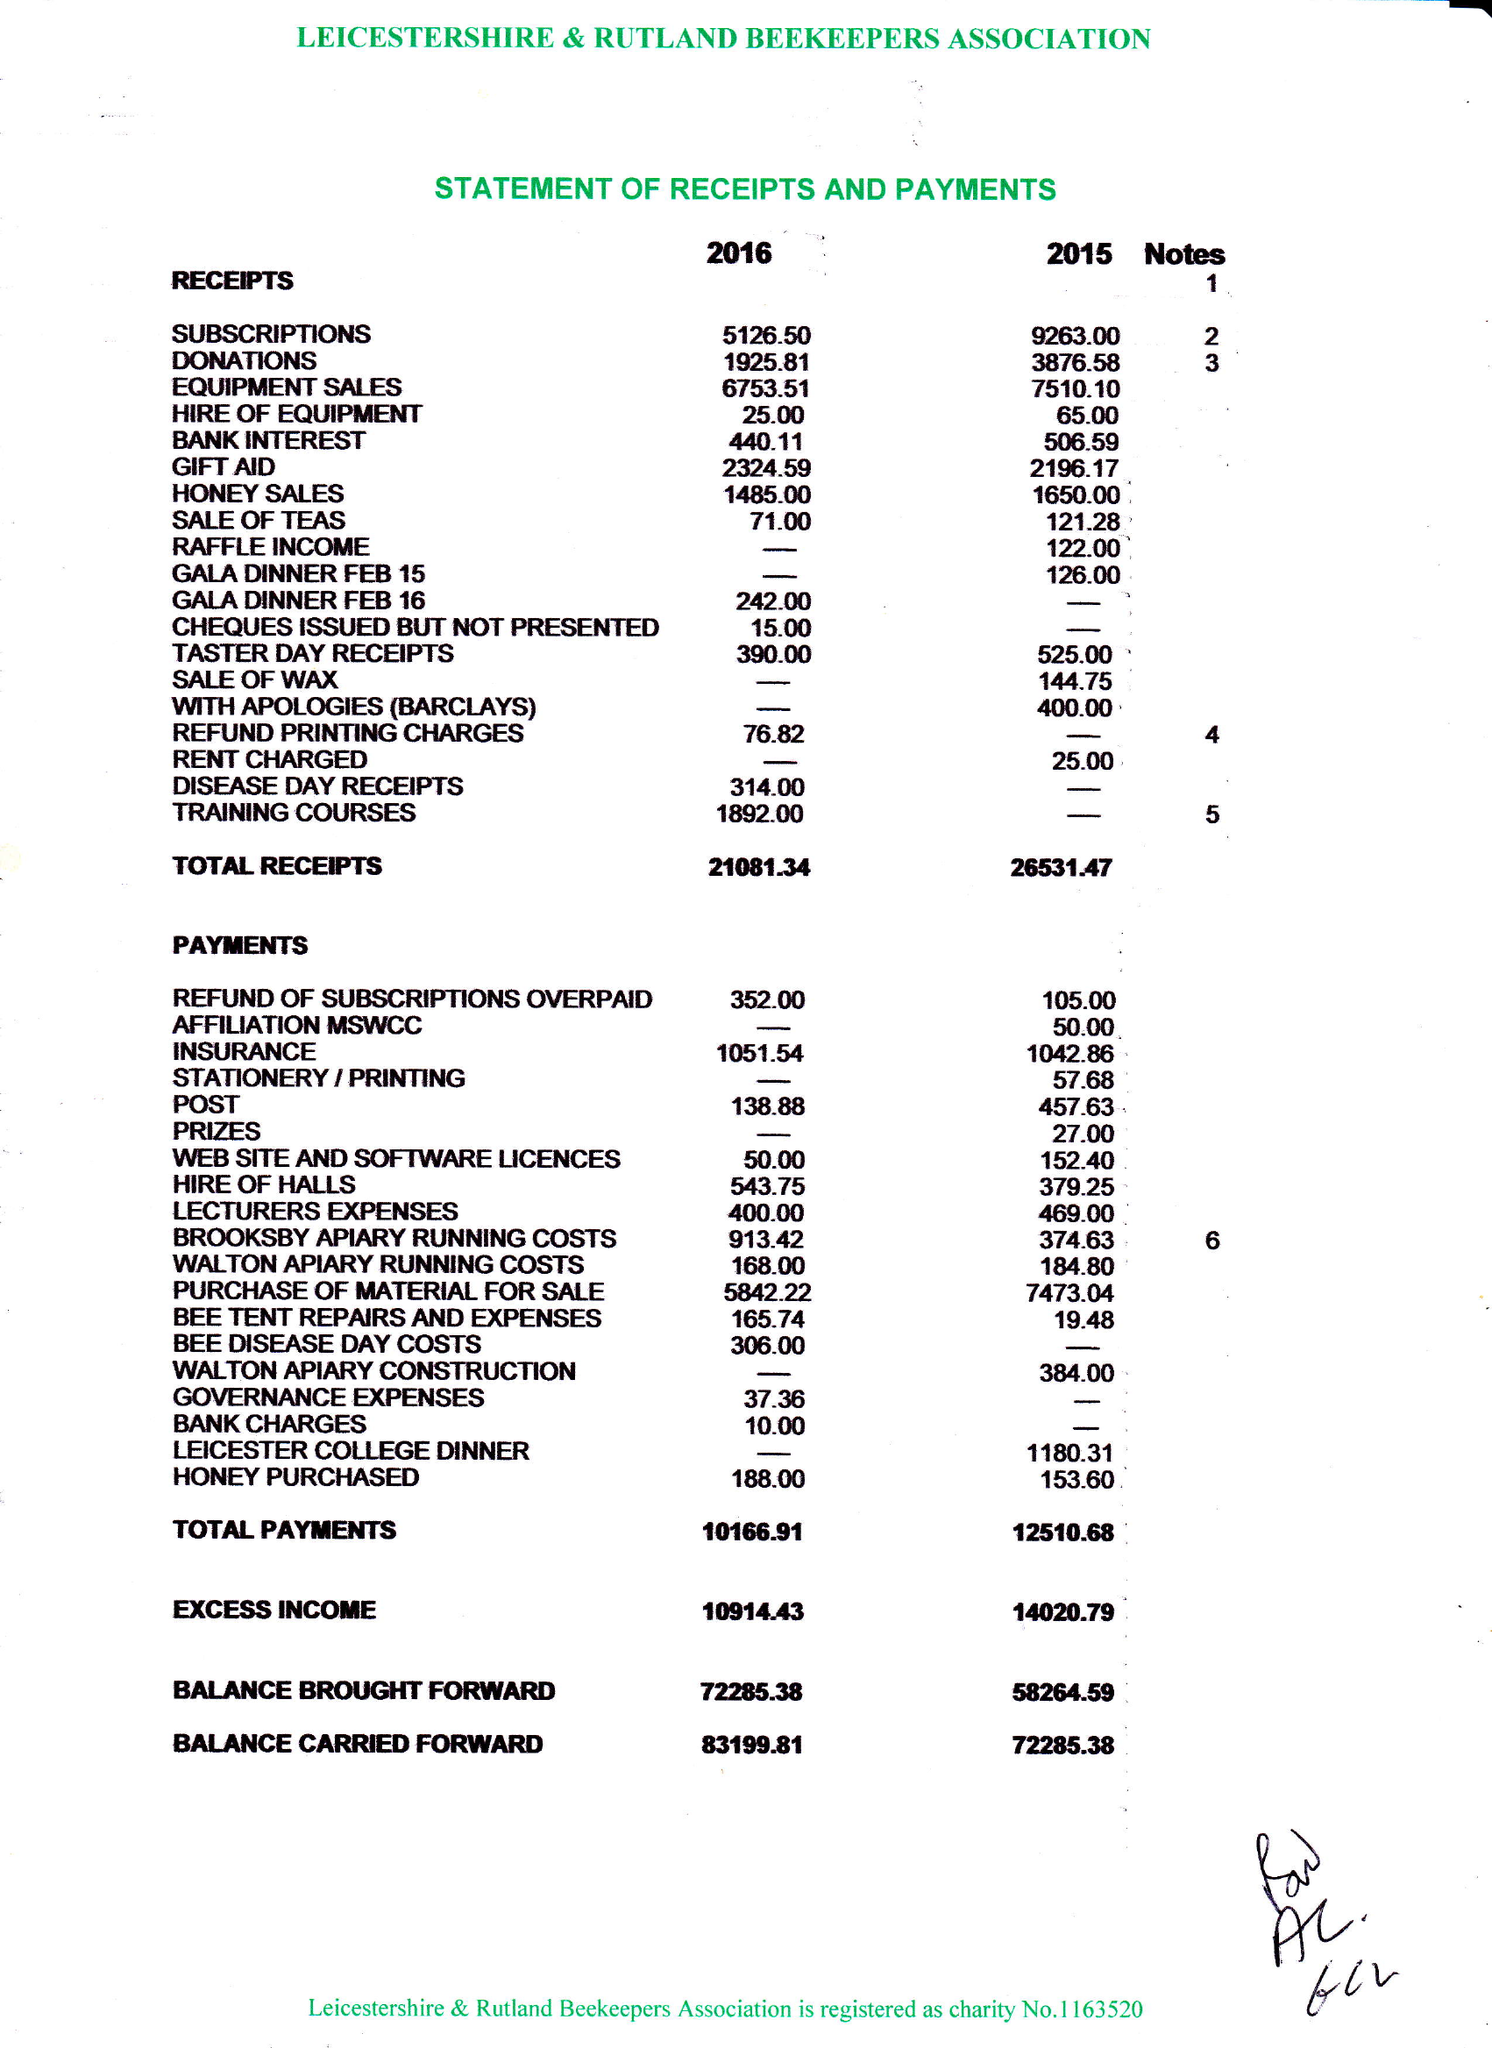What is the value for the charity_name?
Answer the question using a single word or phrase. Leicestershire and Rutland Beekeepers Association 